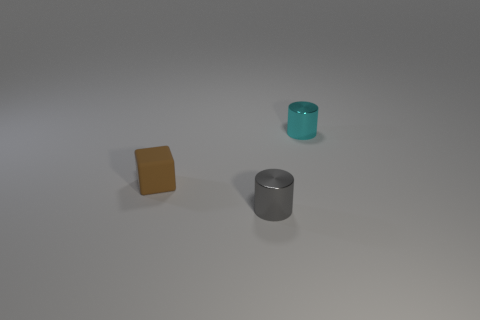Is there any indication of the size of these objects? Without specific reference points in the image, it's difficult to determine the exact size of the objects. However, given their proportions in relation to each other, they seem to be small to medium-sized items that could likely fit comfortably on a desk or shelf. 